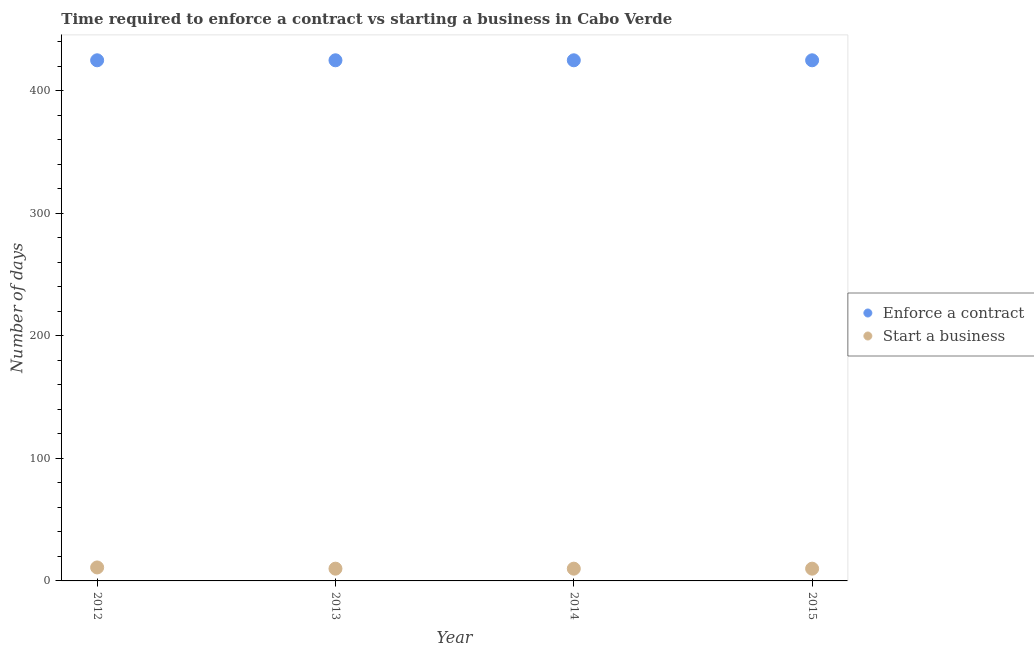Is the number of dotlines equal to the number of legend labels?
Make the answer very short. Yes. What is the number of days to start a business in 2014?
Your response must be concise. 10. Across all years, what is the maximum number of days to start a business?
Provide a short and direct response. 11. Across all years, what is the minimum number of days to enforece a contract?
Give a very brief answer. 425. In which year was the number of days to start a business maximum?
Give a very brief answer. 2012. What is the total number of days to enforece a contract in the graph?
Offer a very short reply. 1700. What is the difference between the number of days to start a business in 2012 and that in 2013?
Your response must be concise. 1. What is the difference between the number of days to enforece a contract in 2012 and the number of days to start a business in 2015?
Make the answer very short. 415. What is the average number of days to start a business per year?
Your answer should be compact. 10.25. In the year 2014, what is the difference between the number of days to enforece a contract and number of days to start a business?
Provide a succinct answer. 415. Is the number of days to enforece a contract in 2014 less than that in 2015?
Ensure brevity in your answer.  No. What is the difference between the highest and the lowest number of days to start a business?
Make the answer very short. 1. In how many years, is the number of days to enforece a contract greater than the average number of days to enforece a contract taken over all years?
Provide a succinct answer. 0. Does the number of days to enforece a contract monotonically increase over the years?
Your answer should be compact. No. Is the number of days to start a business strictly greater than the number of days to enforece a contract over the years?
Provide a short and direct response. No. Is the number of days to enforece a contract strictly less than the number of days to start a business over the years?
Your answer should be very brief. No. How many dotlines are there?
Ensure brevity in your answer.  2. How many years are there in the graph?
Provide a succinct answer. 4. What is the difference between two consecutive major ticks on the Y-axis?
Offer a very short reply. 100. Does the graph contain any zero values?
Your answer should be compact. No. Does the graph contain grids?
Give a very brief answer. No. Where does the legend appear in the graph?
Your answer should be compact. Center right. What is the title of the graph?
Ensure brevity in your answer.  Time required to enforce a contract vs starting a business in Cabo Verde. What is the label or title of the Y-axis?
Make the answer very short. Number of days. What is the Number of days in Enforce a contract in 2012?
Make the answer very short. 425. What is the Number of days in Start a business in 2012?
Provide a succinct answer. 11. What is the Number of days of Enforce a contract in 2013?
Give a very brief answer. 425. What is the Number of days in Enforce a contract in 2014?
Provide a succinct answer. 425. What is the Number of days in Start a business in 2014?
Make the answer very short. 10. What is the Number of days in Enforce a contract in 2015?
Keep it short and to the point. 425. What is the Number of days of Start a business in 2015?
Offer a terse response. 10. Across all years, what is the maximum Number of days in Enforce a contract?
Your response must be concise. 425. Across all years, what is the minimum Number of days of Enforce a contract?
Keep it short and to the point. 425. Across all years, what is the minimum Number of days of Start a business?
Keep it short and to the point. 10. What is the total Number of days of Enforce a contract in the graph?
Offer a very short reply. 1700. What is the total Number of days of Start a business in the graph?
Keep it short and to the point. 41. What is the difference between the Number of days of Start a business in 2012 and that in 2013?
Make the answer very short. 1. What is the difference between the Number of days in Enforce a contract in 2012 and that in 2014?
Offer a very short reply. 0. What is the difference between the Number of days in Enforce a contract in 2012 and that in 2015?
Provide a short and direct response. 0. What is the difference between the Number of days in Start a business in 2012 and that in 2015?
Keep it short and to the point. 1. What is the difference between the Number of days in Enforce a contract in 2014 and that in 2015?
Your response must be concise. 0. What is the difference between the Number of days in Start a business in 2014 and that in 2015?
Your answer should be very brief. 0. What is the difference between the Number of days of Enforce a contract in 2012 and the Number of days of Start a business in 2013?
Offer a terse response. 415. What is the difference between the Number of days in Enforce a contract in 2012 and the Number of days in Start a business in 2014?
Make the answer very short. 415. What is the difference between the Number of days in Enforce a contract in 2012 and the Number of days in Start a business in 2015?
Your answer should be very brief. 415. What is the difference between the Number of days of Enforce a contract in 2013 and the Number of days of Start a business in 2014?
Give a very brief answer. 415. What is the difference between the Number of days of Enforce a contract in 2013 and the Number of days of Start a business in 2015?
Offer a very short reply. 415. What is the difference between the Number of days of Enforce a contract in 2014 and the Number of days of Start a business in 2015?
Your answer should be very brief. 415. What is the average Number of days of Enforce a contract per year?
Offer a very short reply. 425. What is the average Number of days in Start a business per year?
Your response must be concise. 10.25. In the year 2012, what is the difference between the Number of days of Enforce a contract and Number of days of Start a business?
Your answer should be very brief. 414. In the year 2013, what is the difference between the Number of days of Enforce a contract and Number of days of Start a business?
Offer a terse response. 415. In the year 2014, what is the difference between the Number of days of Enforce a contract and Number of days of Start a business?
Ensure brevity in your answer.  415. In the year 2015, what is the difference between the Number of days of Enforce a contract and Number of days of Start a business?
Your answer should be compact. 415. What is the ratio of the Number of days of Enforce a contract in 2012 to that in 2013?
Your answer should be very brief. 1. What is the ratio of the Number of days in Start a business in 2012 to that in 2015?
Keep it short and to the point. 1.1. What is the ratio of the Number of days of Enforce a contract in 2013 to that in 2015?
Give a very brief answer. 1. What is the ratio of the Number of days of Start a business in 2013 to that in 2015?
Your response must be concise. 1. What is the ratio of the Number of days in Enforce a contract in 2014 to that in 2015?
Ensure brevity in your answer.  1. What is the ratio of the Number of days in Start a business in 2014 to that in 2015?
Provide a succinct answer. 1. What is the difference between the highest and the second highest Number of days of Enforce a contract?
Offer a terse response. 0. 